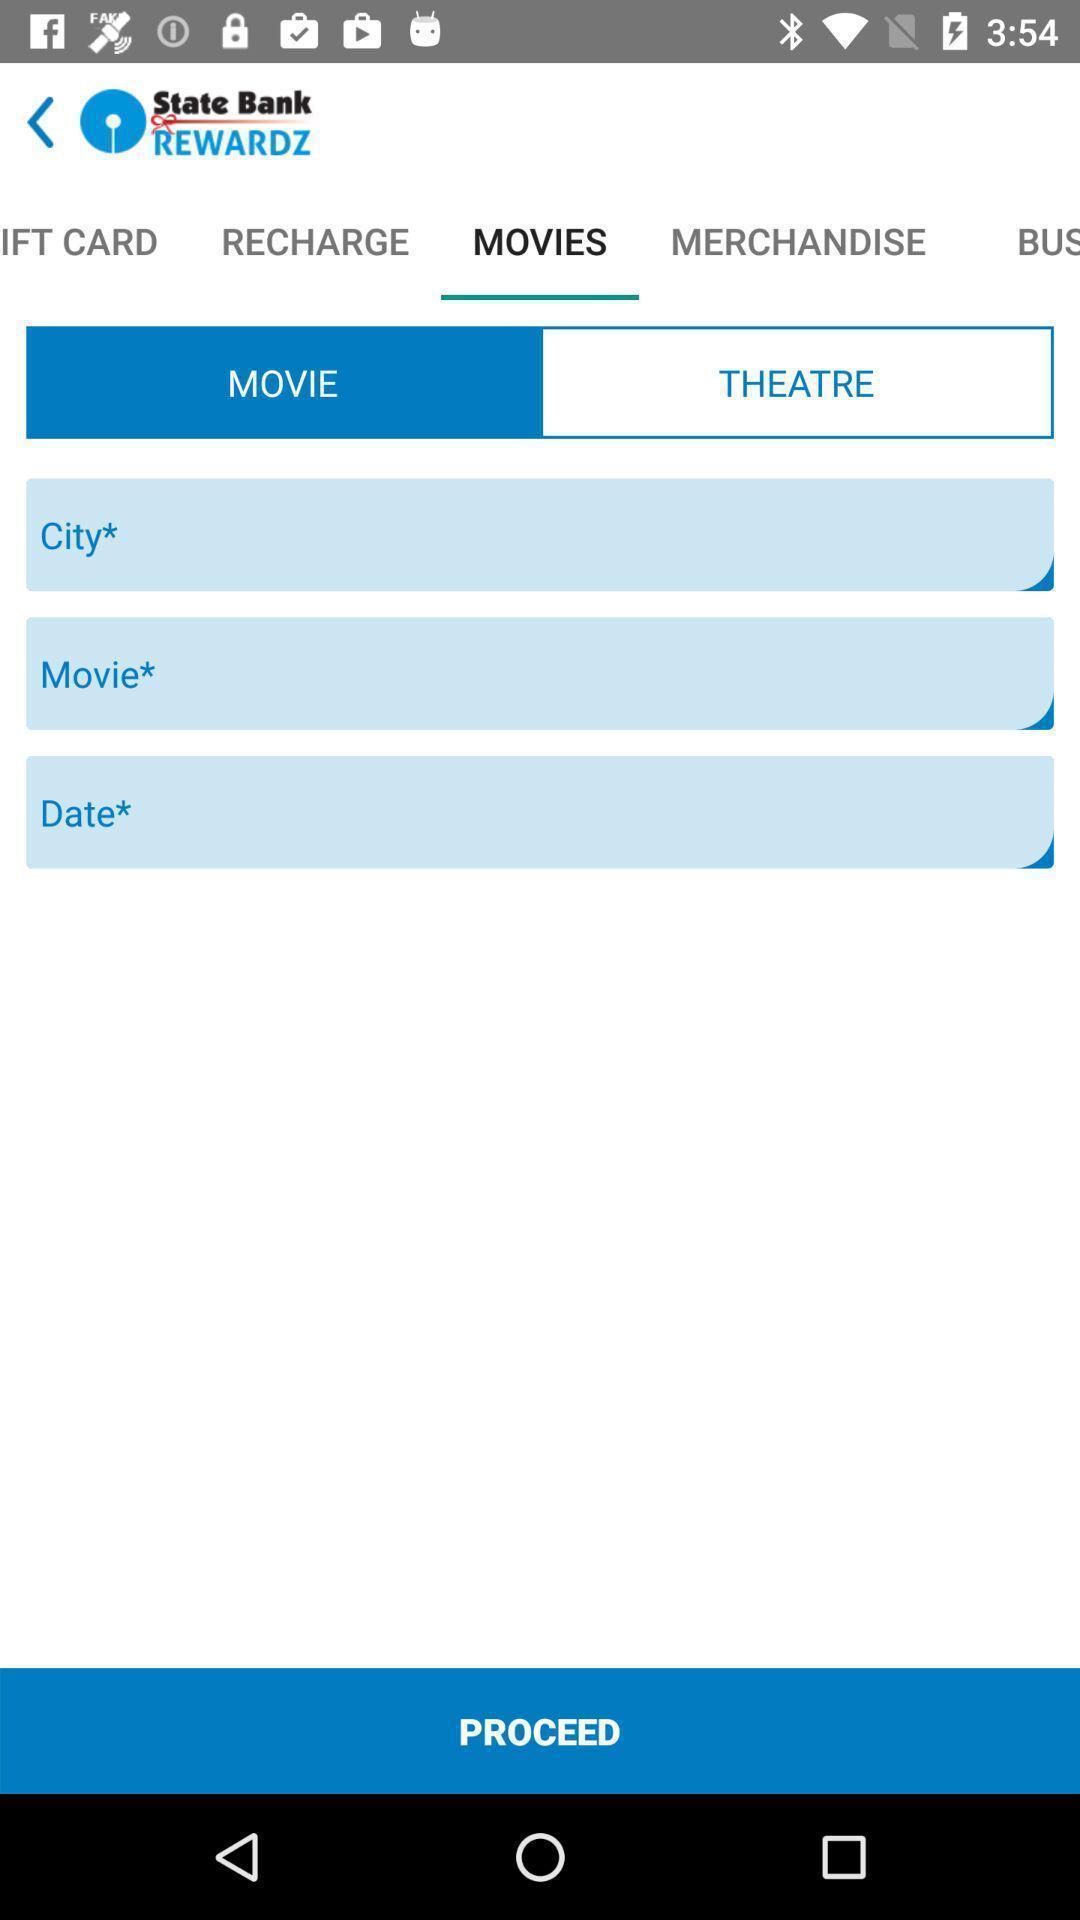Please provide a description for this image. Page displaying the information of the movies through social app. 